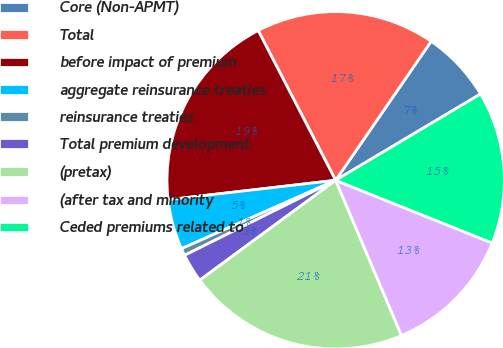Convert chart to OTSL. <chart><loc_0><loc_0><loc_500><loc_500><pie_chart><fcel>Core (Non-APMT)<fcel>Total<fcel>before impact of premium<fcel>aggregate reinsurance treaties<fcel>reinsurance treaties<fcel>Total premium development<fcel>(pretax)<fcel>(after tax and minority<fcel>Ceded premiums related to<nl><fcel>6.87%<fcel>17.18%<fcel>19.24%<fcel>4.81%<fcel>0.69%<fcel>2.75%<fcel>21.3%<fcel>12.55%<fcel>14.61%<nl></chart> 